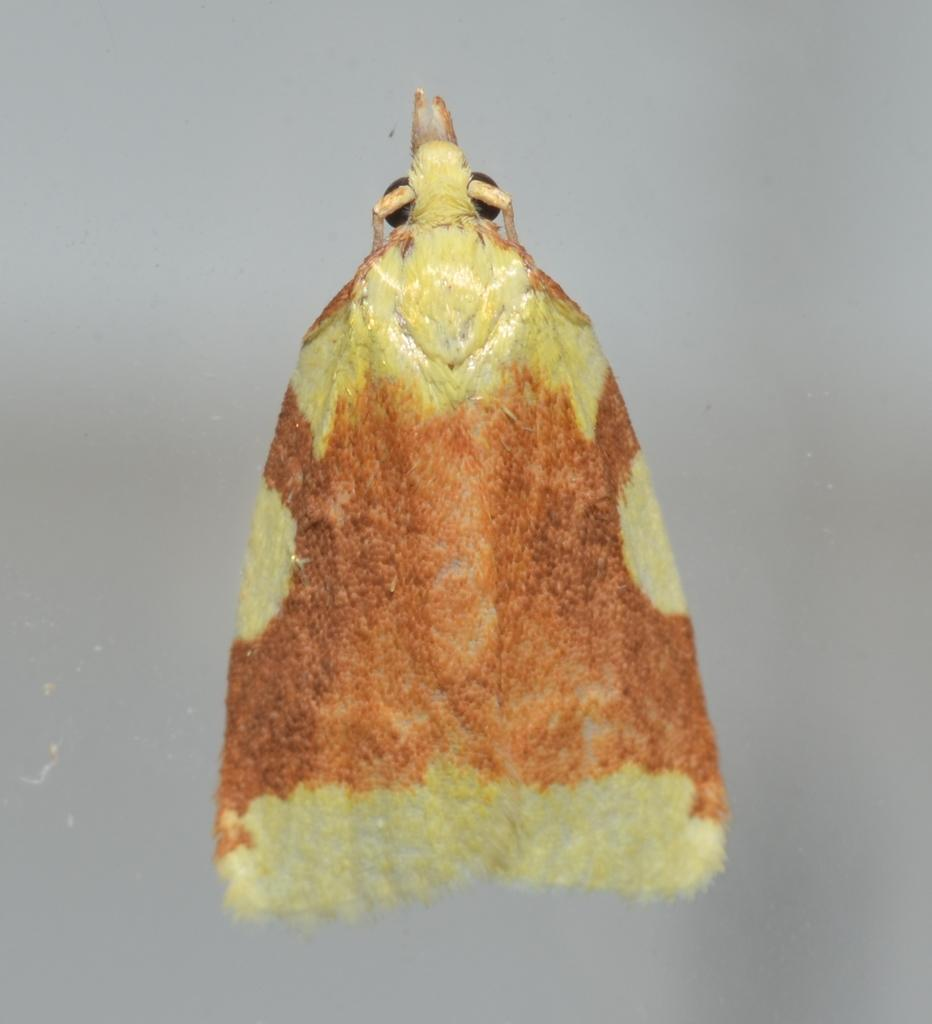What type of insect is in the image? There is a moth in the image. What colors can be seen on the moth? The moth is orange and yellow in color. What is the color of the background in the image? The background of the image is gray. What type of gun is being used to catch the moth in the image? There is no gun present in the image; it only features a moth and a gray background. 